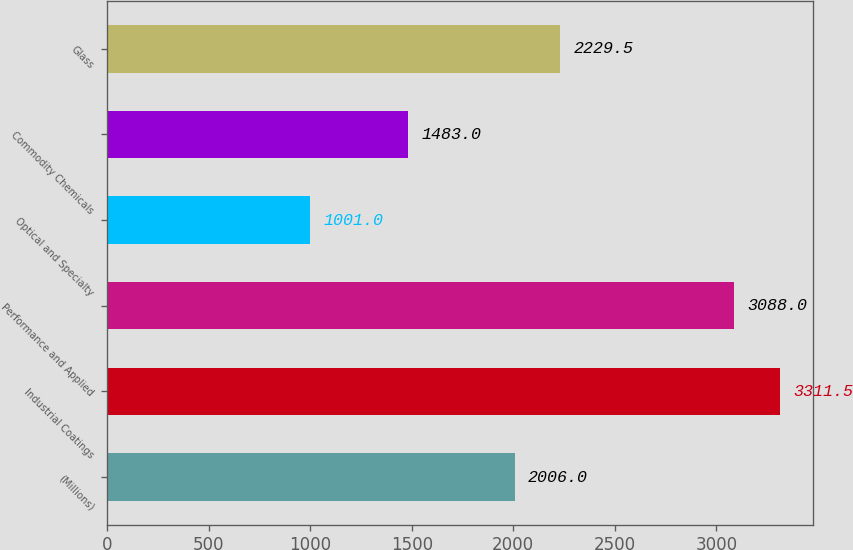<chart> <loc_0><loc_0><loc_500><loc_500><bar_chart><fcel>(Millions)<fcel>Industrial Coatings<fcel>Performance and Applied<fcel>Optical and Specialty<fcel>Commodity Chemicals<fcel>Glass<nl><fcel>2006<fcel>3311.5<fcel>3088<fcel>1001<fcel>1483<fcel>2229.5<nl></chart> 